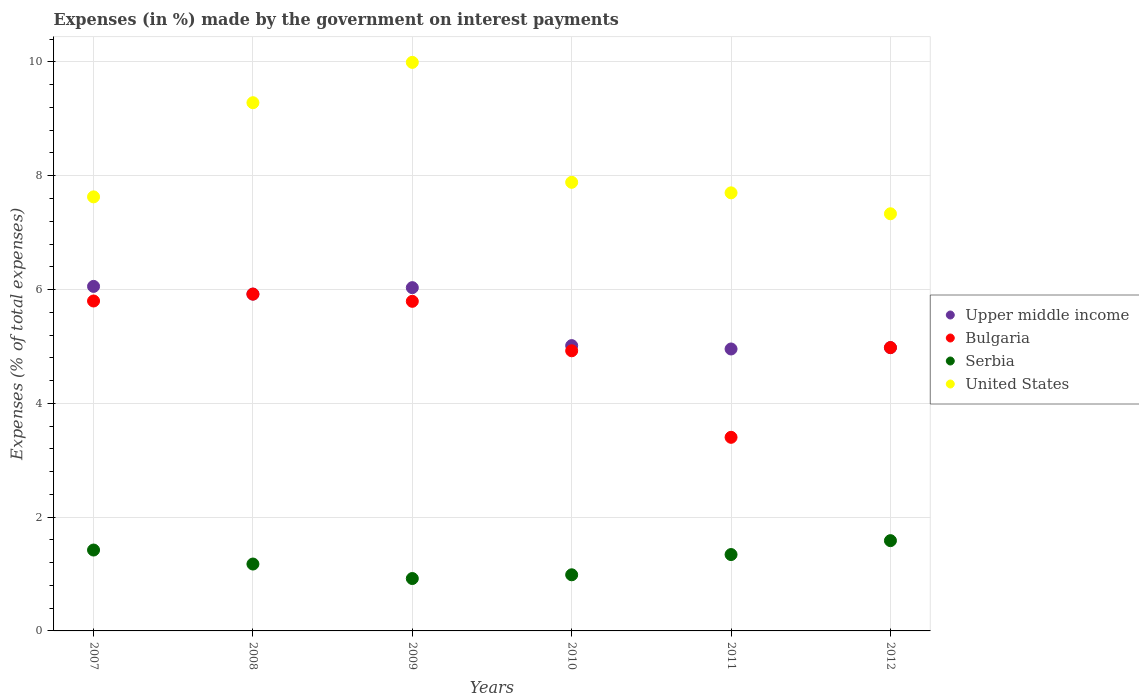How many different coloured dotlines are there?
Make the answer very short. 4. Is the number of dotlines equal to the number of legend labels?
Give a very brief answer. Yes. What is the percentage of expenses made by the government on interest payments in United States in 2008?
Your response must be concise. 9.28. Across all years, what is the maximum percentage of expenses made by the government on interest payments in Bulgaria?
Provide a succinct answer. 5.92. Across all years, what is the minimum percentage of expenses made by the government on interest payments in Bulgaria?
Provide a short and direct response. 3.4. In which year was the percentage of expenses made by the government on interest payments in Bulgaria maximum?
Offer a very short reply. 2008. What is the total percentage of expenses made by the government on interest payments in Serbia in the graph?
Ensure brevity in your answer.  7.43. What is the difference between the percentage of expenses made by the government on interest payments in Upper middle income in 2010 and that in 2012?
Offer a very short reply. 0.03. What is the difference between the percentage of expenses made by the government on interest payments in United States in 2008 and the percentage of expenses made by the government on interest payments in Upper middle income in 2009?
Give a very brief answer. 3.25. What is the average percentage of expenses made by the government on interest payments in Upper middle income per year?
Your answer should be very brief. 5.49. In the year 2010, what is the difference between the percentage of expenses made by the government on interest payments in United States and percentage of expenses made by the government on interest payments in Bulgaria?
Offer a very short reply. 2.96. What is the ratio of the percentage of expenses made by the government on interest payments in Serbia in 2007 to that in 2012?
Make the answer very short. 0.9. What is the difference between the highest and the second highest percentage of expenses made by the government on interest payments in Bulgaria?
Your answer should be compact. 0.12. What is the difference between the highest and the lowest percentage of expenses made by the government on interest payments in Bulgaria?
Offer a very short reply. 2.52. Is the sum of the percentage of expenses made by the government on interest payments in Bulgaria in 2010 and 2011 greater than the maximum percentage of expenses made by the government on interest payments in Upper middle income across all years?
Your answer should be very brief. Yes. Is it the case that in every year, the sum of the percentage of expenses made by the government on interest payments in United States and percentage of expenses made by the government on interest payments in Upper middle income  is greater than the sum of percentage of expenses made by the government on interest payments in Bulgaria and percentage of expenses made by the government on interest payments in Serbia?
Your answer should be compact. Yes. Is it the case that in every year, the sum of the percentage of expenses made by the government on interest payments in United States and percentage of expenses made by the government on interest payments in Bulgaria  is greater than the percentage of expenses made by the government on interest payments in Upper middle income?
Ensure brevity in your answer.  Yes. Does the percentage of expenses made by the government on interest payments in Serbia monotonically increase over the years?
Provide a short and direct response. No. Is the percentage of expenses made by the government on interest payments in United States strictly greater than the percentage of expenses made by the government on interest payments in Upper middle income over the years?
Your response must be concise. Yes. Is the percentage of expenses made by the government on interest payments in Bulgaria strictly less than the percentage of expenses made by the government on interest payments in Upper middle income over the years?
Your answer should be compact. No. How many dotlines are there?
Provide a short and direct response. 4. How many years are there in the graph?
Make the answer very short. 6. What is the difference between two consecutive major ticks on the Y-axis?
Make the answer very short. 2. Are the values on the major ticks of Y-axis written in scientific E-notation?
Ensure brevity in your answer.  No. Does the graph contain any zero values?
Provide a short and direct response. No. How many legend labels are there?
Make the answer very short. 4. How are the legend labels stacked?
Your answer should be very brief. Vertical. What is the title of the graph?
Provide a succinct answer. Expenses (in %) made by the government on interest payments. Does "Czech Republic" appear as one of the legend labels in the graph?
Your response must be concise. No. What is the label or title of the Y-axis?
Make the answer very short. Expenses (% of total expenses). What is the Expenses (% of total expenses) in Upper middle income in 2007?
Give a very brief answer. 6.05. What is the Expenses (% of total expenses) in Bulgaria in 2007?
Offer a terse response. 5.8. What is the Expenses (% of total expenses) of Serbia in 2007?
Give a very brief answer. 1.42. What is the Expenses (% of total expenses) in United States in 2007?
Keep it short and to the point. 7.63. What is the Expenses (% of total expenses) in Upper middle income in 2008?
Ensure brevity in your answer.  5.92. What is the Expenses (% of total expenses) in Bulgaria in 2008?
Provide a succinct answer. 5.92. What is the Expenses (% of total expenses) of Serbia in 2008?
Your response must be concise. 1.18. What is the Expenses (% of total expenses) in United States in 2008?
Provide a succinct answer. 9.28. What is the Expenses (% of total expenses) of Upper middle income in 2009?
Give a very brief answer. 6.03. What is the Expenses (% of total expenses) in Bulgaria in 2009?
Your answer should be very brief. 5.79. What is the Expenses (% of total expenses) in Serbia in 2009?
Offer a terse response. 0.92. What is the Expenses (% of total expenses) of United States in 2009?
Give a very brief answer. 9.99. What is the Expenses (% of total expenses) in Upper middle income in 2010?
Make the answer very short. 5.01. What is the Expenses (% of total expenses) in Bulgaria in 2010?
Keep it short and to the point. 4.92. What is the Expenses (% of total expenses) of Serbia in 2010?
Provide a succinct answer. 0.99. What is the Expenses (% of total expenses) in United States in 2010?
Your response must be concise. 7.88. What is the Expenses (% of total expenses) of Upper middle income in 2011?
Make the answer very short. 4.96. What is the Expenses (% of total expenses) of Bulgaria in 2011?
Offer a very short reply. 3.4. What is the Expenses (% of total expenses) in Serbia in 2011?
Make the answer very short. 1.34. What is the Expenses (% of total expenses) of United States in 2011?
Keep it short and to the point. 7.7. What is the Expenses (% of total expenses) in Upper middle income in 2012?
Your response must be concise. 4.98. What is the Expenses (% of total expenses) of Bulgaria in 2012?
Your answer should be compact. 4.98. What is the Expenses (% of total expenses) of Serbia in 2012?
Your answer should be very brief. 1.59. What is the Expenses (% of total expenses) of United States in 2012?
Provide a succinct answer. 7.33. Across all years, what is the maximum Expenses (% of total expenses) in Upper middle income?
Your answer should be very brief. 6.05. Across all years, what is the maximum Expenses (% of total expenses) of Bulgaria?
Make the answer very short. 5.92. Across all years, what is the maximum Expenses (% of total expenses) in Serbia?
Offer a very short reply. 1.59. Across all years, what is the maximum Expenses (% of total expenses) in United States?
Offer a terse response. 9.99. Across all years, what is the minimum Expenses (% of total expenses) in Upper middle income?
Give a very brief answer. 4.96. Across all years, what is the minimum Expenses (% of total expenses) of Bulgaria?
Provide a short and direct response. 3.4. Across all years, what is the minimum Expenses (% of total expenses) of Serbia?
Keep it short and to the point. 0.92. Across all years, what is the minimum Expenses (% of total expenses) of United States?
Your answer should be very brief. 7.33. What is the total Expenses (% of total expenses) in Upper middle income in the graph?
Ensure brevity in your answer.  32.96. What is the total Expenses (% of total expenses) in Bulgaria in the graph?
Your answer should be very brief. 30.82. What is the total Expenses (% of total expenses) in Serbia in the graph?
Your answer should be compact. 7.43. What is the total Expenses (% of total expenses) of United States in the graph?
Provide a succinct answer. 49.82. What is the difference between the Expenses (% of total expenses) of Upper middle income in 2007 and that in 2008?
Offer a terse response. 0.14. What is the difference between the Expenses (% of total expenses) in Bulgaria in 2007 and that in 2008?
Keep it short and to the point. -0.12. What is the difference between the Expenses (% of total expenses) in Serbia in 2007 and that in 2008?
Your answer should be very brief. 0.25. What is the difference between the Expenses (% of total expenses) of United States in 2007 and that in 2008?
Your answer should be compact. -1.66. What is the difference between the Expenses (% of total expenses) in Upper middle income in 2007 and that in 2009?
Give a very brief answer. 0.02. What is the difference between the Expenses (% of total expenses) in Bulgaria in 2007 and that in 2009?
Provide a succinct answer. 0.01. What is the difference between the Expenses (% of total expenses) of Serbia in 2007 and that in 2009?
Ensure brevity in your answer.  0.5. What is the difference between the Expenses (% of total expenses) in United States in 2007 and that in 2009?
Give a very brief answer. -2.36. What is the difference between the Expenses (% of total expenses) in Upper middle income in 2007 and that in 2010?
Make the answer very short. 1.04. What is the difference between the Expenses (% of total expenses) of Serbia in 2007 and that in 2010?
Offer a terse response. 0.44. What is the difference between the Expenses (% of total expenses) of United States in 2007 and that in 2010?
Offer a very short reply. -0.26. What is the difference between the Expenses (% of total expenses) of Upper middle income in 2007 and that in 2011?
Keep it short and to the point. 1.1. What is the difference between the Expenses (% of total expenses) in Bulgaria in 2007 and that in 2011?
Offer a very short reply. 2.4. What is the difference between the Expenses (% of total expenses) of Serbia in 2007 and that in 2011?
Ensure brevity in your answer.  0.08. What is the difference between the Expenses (% of total expenses) of United States in 2007 and that in 2011?
Provide a succinct answer. -0.07. What is the difference between the Expenses (% of total expenses) of Upper middle income in 2007 and that in 2012?
Provide a short and direct response. 1.08. What is the difference between the Expenses (% of total expenses) in Bulgaria in 2007 and that in 2012?
Your answer should be compact. 0.82. What is the difference between the Expenses (% of total expenses) of Serbia in 2007 and that in 2012?
Offer a very short reply. -0.16. What is the difference between the Expenses (% of total expenses) in United States in 2007 and that in 2012?
Offer a terse response. 0.3. What is the difference between the Expenses (% of total expenses) of Upper middle income in 2008 and that in 2009?
Your response must be concise. -0.11. What is the difference between the Expenses (% of total expenses) of Bulgaria in 2008 and that in 2009?
Give a very brief answer. 0.13. What is the difference between the Expenses (% of total expenses) of Serbia in 2008 and that in 2009?
Provide a short and direct response. 0.25. What is the difference between the Expenses (% of total expenses) in United States in 2008 and that in 2009?
Give a very brief answer. -0.71. What is the difference between the Expenses (% of total expenses) of Upper middle income in 2008 and that in 2010?
Your answer should be very brief. 0.91. What is the difference between the Expenses (% of total expenses) in Serbia in 2008 and that in 2010?
Offer a very short reply. 0.19. What is the difference between the Expenses (% of total expenses) of United States in 2008 and that in 2010?
Give a very brief answer. 1.4. What is the difference between the Expenses (% of total expenses) in Upper middle income in 2008 and that in 2011?
Your answer should be very brief. 0.96. What is the difference between the Expenses (% of total expenses) in Bulgaria in 2008 and that in 2011?
Ensure brevity in your answer.  2.52. What is the difference between the Expenses (% of total expenses) in Serbia in 2008 and that in 2011?
Make the answer very short. -0.17. What is the difference between the Expenses (% of total expenses) in United States in 2008 and that in 2011?
Your answer should be very brief. 1.58. What is the difference between the Expenses (% of total expenses) in Upper middle income in 2008 and that in 2012?
Your answer should be very brief. 0.94. What is the difference between the Expenses (% of total expenses) of Bulgaria in 2008 and that in 2012?
Ensure brevity in your answer.  0.94. What is the difference between the Expenses (% of total expenses) of Serbia in 2008 and that in 2012?
Offer a very short reply. -0.41. What is the difference between the Expenses (% of total expenses) in United States in 2008 and that in 2012?
Your answer should be compact. 1.95. What is the difference between the Expenses (% of total expenses) in Upper middle income in 2009 and that in 2010?
Offer a terse response. 1.02. What is the difference between the Expenses (% of total expenses) in Bulgaria in 2009 and that in 2010?
Provide a succinct answer. 0.87. What is the difference between the Expenses (% of total expenses) in Serbia in 2009 and that in 2010?
Offer a terse response. -0.07. What is the difference between the Expenses (% of total expenses) of United States in 2009 and that in 2010?
Keep it short and to the point. 2.11. What is the difference between the Expenses (% of total expenses) of Upper middle income in 2009 and that in 2011?
Your answer should be very brief. 1.08. What is the difference between the Expenses (% of total expenses) in Bulgaria in 2009 and that in 2011?
Make the answer very short. 2.39. What is the difference between the Expenses (% of total expenses) of Serbia in 2009 and that in 2011?
Your answer should be compact. -0.42. What is the difference between the Expenses (% of total expenses) of United States in 2009 and that in 2011?
Offer a very short reply. 2.29. What is the difference between the Expenses (% of total expenses) in Upper middle income in 2009 and that in 2012?
Your answer should be compact. 1.05. What is the difference between the Expenses (% of total expenses) in Bulgaria in 2009 and that in 2012?
Keep it short and to the point. 0.81. What is the difference between the Expenses (% of total expenses) of Serbia in 2009 and that in 2012?
Ensure brevity in your answer.  -0.67. What is the difference between the Expenses (% of total expenses) of United States in 2009 and that in 2012?
Ensure brevity in your answer.  2.66. What is the difference between the Expenses (% of total expenses) in Upper middle income in 2010 and that in 2011?
Your answer should be compact. 0.06. What is the difference between the Expenses (% of total expenses) in Bulgaria in 2010 and that in 2011?
Give a very brief answer. 1.52. What is the difference between the Expenses (% of total expenses) in Serbia in 2010 and that in 2011?
Keep it short and to the point. -0.36. What is the difference between the Expenses (% of total expenses) in United States in 2010 and that in 2011?
Keep it short and to the point. 0.19. What is the difference between the Expenses (% of total expenses) of Upper middle income in 2010 and that in 2012?
Offer a terse response. 0.03. What is the difference between the Expenses (% of total expenses) of Bulgaria in 2010 and that in 2012?
Provide a short and direct response. -0.06. What is the difference between the Expenses (% of total expenses) of United States in 2010 and that in 2012?
Provide a succinct answer. 0.55. What is the difference between the Expenses (% of total expenses) in Upper middle income in 2011 and that in 2012?
Offer a terse response. -0.02. What is the difference between the Expenses (% of total expenses) in Bulgaria in 2011 and that in 2012?
Give a very brief answer. -1.58. What is the difference between the Expenses (% of total expenses) of Serbia in 2011 and that in 2012?
Offer a very short reply. -0.24. What is the difference between the Expenses (% of total expenses) of United States in 2011 and that in 2012?
Make the answer very short. 0.37. What is the difference between the Expenses (% of total expenses) in Upper middle income in 2007 and the Expenses (% of total expenses) in Bulgaria in 2008?
Give a very brief answer. 0.14. What is the difference between the Expenses (% of total expenses) in Upper middle income in 2007 and the Expenses (% of total expenses) in Serbia in 2008?
Provide a succinct answer. 4.88. What is the difference between the Expenses (% of total expenses) of Upper middle income in 2007 and the Expenses (% of total expenses) of United States in 2008?
Keep it short and to the point. -3.23. What is the difference between the Expenses (% of total expenses) of Bulgaria in 2007 and the Expenses (% of total expenses) of Serbia in 2008?
Offer a terse response. 4.62. What is the difference between the Expenses (% of total expenses) in Bulgaria in 2007 and the Expenses (% of total expenses) in United States in 2008?
Make the answer very short. -3.48. What is the difference between the Expenses (% of total expenses) in Serbia in 2007 and the Expenses (% of total expenses) in United States in 2008?
Give a very brief answer. -7.86. What is the difference between the Expenses (% of total expenses) in Upper middle income in 2007 and the Expenses (% of total expenses) in Bulgaria in 2009?
Your answer should be compact. 0.26. What is the difference between the Expenses (% of total expenses) in Upper middle income in 2007 and the Expenses (% of total expenses) in Serbia in 2009?
Offer a terse response. 5.13. What is the difference between the Expenses (% of total expenses) in Upper middle income in 2007 and the Expenses (% of total expenses) in United States in 2009?
Provide a succinct answer. -3.94. What is the difference between the Expenses (% of total expenses) of Bulgaria in 2007 and the Expenses (% of total expenses) of Serbia in 2009?
Provide a short and direct response. 4.88. What is the difference between the Expenses (% of total expenses) of Bulgaria in 2007 and the Expenses (% of total expenses) of United States in 2009?
Ensure brevity in your answer.  -4.19. What is the difference between the Expenses (% of total expenses) in Serbia in 2007 and the Expenses (% of total expenses) in United States in 2009?
Offer a very short reply. -8.57. What is the difference between the Expenses (% of total expenses) of Upper middle income in 2007 and the Expenses (% of total expenses) of Bulgaria in 2010?
Make the answer very short. 1.13. What is the difference between the Expenses (% of total expenses) in Upper middle income in 2007 and the Expenses (% of total expenses) in Serbia in 2010?
Give a very brief answer. 5.07. What is the difference between the Expenses (% of total expenses) in Upper middle income in 2007 and the Expenses (% of total expenses) in United States in 2010?
Offer a very short reply. -1.83. What is the difference between the Expenses (% of total expenses) in Bulgaria in 2007 and the Expenses (% of total expenses) in Serbia in 2010?
Make the answer very short. 4.81. What is the difference between the Expenses (% of total expenses) in Bulgaria in 2007 and the Expenses (% of total expenses) in United States in 2010?
Your response must be concise. -2.09. What is the difference between the Expenses (% of total expenses) of Serbia in 2007 and the Expenses (% of total expenses) of United States in 2010?
Your answer should be compact. -6.46. What is the difference between the Expenses (% of total expenses) of Upper middle income in 2007 and the Expenses (% of total expenses) of Bulgaria in 2011?
Ensure brevity in your answer.  2.65. What is the difference between the Expenses (% of total expenses) in Upper middle income in 2007 and the Expenses (% of total expenses) in Serbia in 2011?
Give a very brief answer. 4.71. What is the difference between the Expenses (% of total expenses) in Upper middle income in 2007 and the Expenses (% of total expenses) in United States in 2011?
Your answer should be very brief. -1.64. What is the difference between the Expenses (% of total expenses) in Bulgaria in 2007 and the Expenses (% of total expenses) in Serbia in 2011?
Provide a short and direct response. 4.46. What is the difference between the Expenses (% of total expenses) of Bulgaria in 2007 and the Expenses (% of total expenses) of United States in 2011?
Give a very brief answer. -1.9. What is the difference between the Expenses (% of total expenses) in Serbia in 2007 and the Expenses (% of total expenses) in United States in 2011?
Provide a succinct answer. -6.28. What is the difference between the Expenses (% of total expenses) of Upper middle income in 2007 and the Expenses (% of total expenses) of Bulgaria in 2012?
Your response must be concise. 1.08. What is the difference between the Expenses (% of total expenses) in Upper middle income in 2007 and the Expenses (% of total expenses) in Serbia in 2012?
Your answer should be very brief. 4.47. What is the difference between the Expenses (% of total expenses) of Upper middle income in 2007 and the Expenses (% of total expenses) of United States in 2012?
Your answer should be compact. -1.28. What is the difference between the Expenses (% of total expenses) of Bulgaria in 2007 and the Expenses (% of total expenses) of Serbia in 2012?
Your answer should be very brief. 4.21. What is the difference between the Expenses (% of total expenses) of Bulgaria in 2007 and the Expenses (% of total expenses) of United States in 2012?
Your answer should be compact. -1.53. What is the difference between the Expenses (% of total expenses) of Serbia in 2007 and the Expenses (% of total expenses) of United States in 2012?
Your response must be concise. -5.91. What is the difference between the Expenses (% of total expenses) in Upper middle income in 2008 and the Expenses (% of total expenses) in Bulgaria in 2009?
Offer a very short reply. 0.13. What is the difference between the Expenses (% of total expenses) of Upper middle income in 2008 and the Expenses (% of total expenses) of Serbia in 2009?
Provide a succinct answer. 5. What is the difference between the Expenses (% of total expenses) of Upper middle income in 2008 and the Expenses (% of total expenses) of United States in 2009?
Give a very brief answer. -4.07. What is the difference between the Expenses (% of total expenses) in Bulgaria in 2008 and the Expenses (% of total expenses) in Serbia in 2009?
Ensure brevity in your answer.  5. What is the difference between the Expenses (% of total expenses) in Bulgaria in 2008 and the Expenses (% of total expenses) in United States in 2009?
Offer a very short reply. -4.07. What is the difference between the Expenses (% of total expenses) of Serbia in 2008 and the Expenses (% of total expenses) of United States in 2009?
Your answer should be compact. -8.82. What is the difference between the Expenses (% of total expenses) in Upper middle income in 2008 and the Expenses (% of total expenses) in Serbia in 2010?
Your response must be concise. 4.93. What is the difference between the Expenses (% of total expenses) in Upper middle income in 2008 and the Expenses (% of total expenses) in United States in 2010?
Give a very brief answer. -1.96. What is the difference between the Expenses (% of total expenses) of Bulgaria in 2008 and the Expenses (% of total expenses) of Serbia in 2010?
Offer a very short reply. 4.93. What is the difference between the Expenses (% of total expenses) of Bulgaria in 2008 and the Expenses (% of total expenses) of United States in 2010?
Ensure brevity in your answer.  -1.96. What is the difference between the Expenses (% of total expenses) in Serbia in 2008 and the Expenses (% of total expenses) in United States in 2010?
Your response must be concise. -6.71. What is the difference between the Expenses (% of total expenses) of Upper middle income in 2008 and the Expenses (% of total expenses) of Bulgaria in 2011?
Your answer should be very brief. 2.52. What is the difference between the Expenses (% of total expenses) of Upper middle income in 2008 and the Expenses (% of total expenses) of Serbia in 2011?
Offer a terse response. 4.58. What is the difference between the Expenses (% of total expenses) in Upper middle income in 2008 and the Expenses (% of total expenses) in United States in 2011?
Give a very brief answer. -1.78. What is the difference between the Expenses (% of total expenses) of Bulgaria in 2008 and the Expenses (% of total expenses) of Serbia in 2011?
Keep it short and to the point. 4.58. What is the difference between the Expenses (% of total expenses) in Bulgaria in 2008 and the Expenses (% of total expenses) in United States in 2011?
Your answer should be very brief. -1.78. What is the difference between the Expenses (% of total expenses) of Serbia in 2008 and the Expenses (% of total expenses) of United States in 2011?
Give a very brief answer. -6.52. What is the difference between the Expenses (% of total expenses) of Upper middle income in 2008 and the Expenses (% of total expenses) of Bulgaria in 2012?
Keep it short and to the point. 0.94. What is the difference between the Expenses (% of total expenses) of Upper middle income in 2008 and the Expenses (% of total expenses) of Serbia in 2012?
Ensure brevity in your answer.  4.33. What is the difference between the Expenses (% of total expenses) in Upper middle income in 2008 and the Expenses (% of total expenses) in United States in 2012?
Offer a very short reply. -1.41. What is the difference between the Expenses (% of total expenses) of Bulgaria in 2008 and the Expenses (% of total expenses) of Serbia in 2012?
Provide a succinct answer. 4.33. What is the difference between the Expenses (% of total expenses) in Bulgaria in 2008 and the Expenses (% of total expenses) in United States in 2012?
Keep it short and to the point. -1.41. What is the difference between the Expenses (% of total expenses) of Serbia in 2008 and the Expenses (% of total expenses) of United States in 2012?
Your response must be concise. -6.16. What is the difference between the Expenses (% of total expenses) of Upper middle income in 2009 and the Expenses (% of total expenses) of Bulgaria in 2010?
Give a very brief answer. 1.11. What is the difference between the Expenses (% of total expenses) of Upper middle income in 2009 and the Expenses (% of total expenses) of Serbia in 2010?
Your response must be concise. 5.05. What is the difference between the Expenses (% of total expenses) of Upper middle income in 2009 and the Expenses (% of total expenses) of United States in 2010?
Your answer should be very brief. -1.85. What is the difference between the Expenses (% of total expenses) in Bulgaria in 2009 and the Expenses (% of total expenses) in Serbia in 2010?
Make the answer very short. 4.81. What is the difference between the Expenses (% of total expenses) of Bulgaria in 2009 and the Expenses (% of total expenses) of United States in 2010?
Your answer should be compact. -2.09. What is the difference between the Expenses (% of total expenses) of Serbia in 2009 and the Expenses (% of total expenses) of United States in 2010?
Ensure brevity in your answer.  -6.96. What is the difference between the Expenses (% of total expenses) in Upper middle income in 2009 and the Expenses (% of total expenses) in Bulgaria in 2011?
Your response must be concise. 2.63. What is the difference between the Expenses (% of total expenses) in Upper middle income in 2009 and the Expenses (% of total expenses) in Serbia in 2011?
Offer a very short reply. 4.69. What is the difference between the Expenses (% of total expenses) in Upper middle income in 2009 and the Expenses (% of total expenses) in United States in 2011?
Your answer should be compact. -1.67. What is the difference between the Expenses (% of total expenses) in Bulgaria in 2009 and the Expenses (% of total expenses) in Serbia in 2011?
Make the answer very short. 4.45. What is the difference between the Expenses (% of total expenses) of Bulgaria in 2009 and the Expenses (% of total expenses) of United States in 2011?
Your answer should be very brief. -1.91. What is the difference between the Expenses (% of total expenses) of Serbia in 2009 and the Expenses (% of total expenses) of United States in 2011?
Offer a terse response. -6.78. What is the difference between the Expenses (% of total expenses) of Upper middle income in 2009 and the Expenses (% of total expenses) of Bulgaria in 2012?
Make the answer very short. 1.05. What is the difference between the Expenses (% of total expenses) in Upper middle income in 2009 and the Expenses (% of total expenses) in Serbia in 2012?
Your response must be concise. 4.45. What is the difference between the Expenses (% of total expenses) in Upper middle income in 2009 and the Expenses (% of total expenses) in United States in 2012?
Your answer should be very brief. -1.3. What is the difference between the Expenses (% of total expenses) in Bulgaria in 2009 and the Expenses (% of total expenses) in Serbia in 2012?
Offer a very short reply. 4.21. What is the difference between the Expenses (% of total expenses) in Bulgaria in 2009 and the Expenses (% of total expenses) in United States in 2012?
Provide a short and direct response. -1.54. What is the difference between the Expenses (% of total expenses) in Serbia in 2009 and the Expenses (% of total expenses) in United States in 2012?
Your answer should be compact. -6.41. What is the difference between the Expenses (% of total expenses) in Upper middle income in 2010 and the Expenses (% of total expenses) in Bulgaria in 2011?
Ensure brevity in your answer.  1.61. What is the difference between the Expenses (% of total expenses) in Upper middle income in 2010 and the Expenses (% of total expenses) in Serbia in 2011?
Your answer should be very brief. 3.67. What is the difference between the Expenses (% of total expenses) of Upper middle income in 2010 and the Expenses (% of total expenses) of United States in 2011?
Make the answer very short. -2.68. What is the difference between the Expenses (% of total expenses) of Bulgaria in 2010 and the Expenses (% of total expenses) of Serbia in 2011?
Give a very brief answer. 3.58. What is the difference between the Expenses (% of total expenses) in Bulgaria in 2010 and the Expenses (% of total expenses) in United States in 2011?
Make the answer very short. -2.78. What is the difference between the Expenses (% of total expenses) of Serbia in 2010 and the Expenses (% of total expenses) of United States in 2011?
Keep it short and to the point. -6.71. What is the difference between the Expenses (% of total expenses) of Upper middle income in 2010 and the Expenses (% of total expenses) of Bulgaria in 2012?
Your answer should be compact. 0.03. What is the difference between the Expenses (% of total expenses) of Upper middle income in 2010 and the Expenses (% of total expenses) of Serbia in 2012?
Provide a succinct answer. 3.43. What is the difference between the Expenses (% of total expenses) of Upper middle income in 2010 and the Expenses (% of total expenses) of United States in 2012?
Your response must be concise. -2.32. What is the difference between the Expenses (% of total expenses) of Bulgaria in 2010 and the Expenses (% of total expenses) of Serbia in 2012?
Make the answer very short. 3.34. What is the difference between the Expenses (% of total expenses) in Bulgaria in 2010 and the Expenses (% of total expenses) in United States in 2012?
Offer a terse response. -2.41. What is the difference between the Expenses (% of total expenses) in Serbia in 2010 and the Expenses (% of total expenses) in United States in 2012?
Your answer should be compact. -6.34. What is the difference between the Expenses (% of total expenses) in Upper middle income in 2011 and the Expenses (% of total expenses) in Bulgaria in 2012?
Make the answer very short. -0.02. What is the difference between the Expenses (% of total expenses) of Upper middle income in 2011 and the Expenses (% of total expenses) of Serbia in 2012?
Your response must be concise. 3.37. What is the difference between the Expenses (% of total expenses) of Upper middle income in 2011 and the Expenses (% of total expenses) of United States in 2012?
Keep it short and to the point. -2.38. What is the difference between the Expenses (% of total expenses) in Bulgaria in 2011 and the Expenses (% of total expenses) in Serbia in 2012?
Keep it short and to the point. 1.82. What is the difference between the Expenses (% of total expenses) of Bulgaria in 2011 and the Expenses (% of total expenses) of United States in 2012?
Offer a very short reply. -3.93. What is the difference between the Expenses (% of total expenses) of Serbia in 2011 and the Expenses (% of total expenses) of United States in 2012?
Offer a terse response. -5.99. What is the average Expenses (% of total expenses) in Upper middle income per year?
Offer a very short reply. 5.49. What is the average Expenses (% of total expenses) in Bulgaria per year?
Make the answer very short. 5.14. What is the average Expenses (% of total expenses) of Serbia per year?
Keep it short and to the point. 1.24. What is the average Expenses (% of total expenses) in United States per year?
Offer a very short reply. 8.3. In the year 2007, what is the difference between the Expenses (% of total expenses) of Upper middle income and Expenses (% of total expenses) of Bulgaria?
Your response must be concise. 0.26. In the year 2007, what is the difference between the Expenses (% of total expenses) in Upper middle income and Expenses (% of total expenses) in Serbia?
Your answer should be very brief. 4.63. In the year 2007, what is the difference between the Expenses (% of total expenses) of Upper middle income and Expenses (% of total expenses) of United States?
Provide a succinct answer. -1.57. In the year 2007, what is the difference between the Expenses (% of total expenses) in Bulgaria and Expenses (% of total expenses) in Serbia?
Provide a succinct answer. 4.38. In the year 2007, what is the difference between the Expenses (% of total expenses) of Bulgaria and Expenses (% of total expenses) of United States?
Your answer should be compact. -1.83. In the year 2007, what is the difference between the Expenses (% of total expenses) in Serbia and Expenses (% of total expenses) in United States?
Your answer should be compact. -6.21. In the year 2008, what is the difference between the Expenses (% of total expenses) of Upper middle income and Expenses (% of total expenses) of Serbia?
Provide a short and direct response. 4.74. In the year 2008, what is the difference between the Expenses (% of total expenses) of Upper middle income and Expenses (% of total expenses) of United States?
Provide a short and direct response. -3.36. In the year 2008, what is the difference between the Expenses (% of total expenses) in Bulgaria and Expenses (% of total expenses) in Serbia?
Provide a succinct answer. 4.74. In the year 2008, what is the difference between the Expenses (% of total expenses) in Bulgaria and Expenses (% of total expenses) in United States?
Ensure brevity in your answer.  -3.36. In the year 2008, what is the difference between the Expenses (% of total expenses) of Serbia and Expenses (% of total expenses) of United States?
Offer a terse response. -8.11. In the year 2009, what is the difference between the Expenses (% of total expenses) in Upper middle income and Expenses (% of total expenses) in Bulgaria?
Make the answer very short. 0.24. In the year 2009, what is the difference between the Expenses (% of total expenses) in Upper middle income and Expenses (% of total expenses) in Serbia?
Provide a succinct answer. 5.11. In the year 2009, what is the difference between the Expenses (% of total expenses) of Upper middle income and Expenses (% of total expenses) of United States?
Offer a very short reply. -3.96. In the year 2009, what is the difference between the Expenses (% of total expenses) in Bulgaria and Expenses (% of total expenses) in Serbia?
Give a very brief answer. 4.87. In the year 2009, what is the difference between the Expenses (% of total expenses) in Bulgaria and Expenses (% of total expenses) in United States?
Offer a terse response. -4.2. In the year 2009, what is the difference between the Expenses (% of total expenses) of Serbia and Expenses (% of total expenses) of United States?
Your answer should be compact. -9.07. In the year 2010, what is the difference between the Expenses (% of total expenses) in Upper middle income and Expenses (% of total expenses) in Bulgaria?
Make the answer very short. 0.09. In the year 2010, what is the difference between the Expenses (% of total expenses) of Upper middle income and Expenses (% of total expenses) of Serbia?
Provide a short and direct response. 4.03. In the year 2010, what is the difference between the Expenses (% of total expenses) in Upper middle income and Expenses (% of total expenses) in United States?
Provide a succinct answer. -2.87. In the year 2010, what is the difference between the Expenses (% of total expenses) in Bulgaria and Expenses (% of total expenses) in Serbia?
Make the answer very short. 3.94. In the year 2010, what is the difference between the Expenses (% of total expenses) in Bulgaria and Expenses (% of total expenses) in United States?
Keep it short and to the point. -2.96. In the year 2010, what is the difference between the Expenses (% of total expenses) of Serbia and Expenses (% of total expenses) of United States?
Offer a very short reply. -6.9. In the year 2011, what is the difference between the Expenses (% of total expenses) of Upper middle income and Expenses (% of total expenses) of Bulgaria?
Give a very brief answer. 1.55. In the year 2011, what is the difference between the Expenses (% of total expenses) in Upper middle income and Expenses (% of total expenses) in Serbia?
Your answer should be very brief. 3.61. In the year 2011, what is the difference between the Expenses (% of total expenses) of Upper middle income and Expenses (% of total expenses) of United States?
Keep it short and to the point. -2.74. In the year 2011, what is the difference between the Expenses (% of total expenses) of Bulgaria and Expenses (% of total expenses) of Serbia?
Make the answer very short. 2.06. In the year 2011, what is the difference between the Expenses (% of total expenses) in Bulgaria and Expenses (% of total expenses) in United States?
Your answer should be very brief. -4.3. In the year 2011, what is the difference between the Expenses (% of total expenses) in Serbia and Expenses (% of total expenses) in United States?
Offer a terse response. -6.36. In the year 2012, what is the difference between the Expenses (% of total expenses) of Upper middle income and Expenses (% of total expenses) of Serbia?
Your response must be concise. 3.39. In the year 2012, what is the difference between the Expenses (% of total expenses) of Upper middle income and Expenses (% of total expenses) of United States?
Give a very brief answer. -2.35. In the year 2012, what is the difference between the Expenses (% of total expenses) of Bulgaria and Expenses (% of total expenses) of Serbia?
Keep it short and to the point. 3.39. In the year 2012, what is the difference between the Expenses (% of total expenses) in Bulgaria and Expenses (% of total expenses) in United States?
Offer a terse response. -2.35. In the year 2012, what is the difference between the Expenses (% of total expenses) of Serbia and Expenses (% of total expenses) of United States?
Offer a very short reply. -5.74. What is the ratio of the Expenses (% of total expenses) in Upper middle income in 2007 to that in 2008?
Ensure brevity in your answer.  1.02. What is the ratio of the Expenses (% of total expenses) in Bulgaria in 2007 to that in 2008?
Offer a very short reply. 0.98. What is the ratio of the Expenses (% of total expenses) in Serbia in 2007 to that in 2008?
Your response must be concise. 1.21. What is the ratio of the Expenses (% of total expenses) in United States in 2007 to that in 2008?
Make the answer very short. 0.82. What is the ratio of the Expenses (% of total expenses) in Bulgaria in 2007 to that in 2009?
Provide a succinct answer. 1. What is the ratio of the Expenses (% of total expenses) of Serbia in 2007 to that in 2009?
Give a very brief answer. 1.54. What is the ratio of the Expenses (% of total expenses) in United States in 2007 to that in 2009?
Offer a terse response. 0.76. What is the ratio of the Expenses (% of total expenses) of Upper middle income in 2007 to that in 2010?
Keep it short and to the point. 1.21. What is the ratio of the Expenses (% of total expenses) in Bulgaria in 2007 to that in 2010?
Give a very brief answer. 1.18. What is the ratio of the Expenses (% of total expenses) of Serbia in 2007 to that in 2010?
Keep it short and to the point. 1.44. What is the ratio of the Expenses (% of total expenses) of United States in 2007 to that in 2010?
Give a very brief answer. 0.97. What is the ratio of the Expenses (% of total expenses) in Upper middle income in 2007 to that in 2011?
Keep it short and to the point. 1.22. What is the ratio of the Expenses (% of total expenses) in Bulgaria in 2007 to that in 2011?
Give a very brief answer. 1.7. What is the ratio of the Expenses (% of total expenses) in Serbia in 2007 to that in 2011?
Ensure brevity in your answer.  1.06. What is the ratio of the Expenses (% of total expenses) of Upper middle income in 2007 to that in 2012?
Make the answer very short. 1.22. What is the ratio of the Expenses (% of total expenses) in Bulgaria in 2007 to that in 2012?
Give a very brief answer. 1.16. What is the ratio of the Expenses (% of total expenses) in Serbia in 2007 to that in 2012?
Provide a short and direct response. 0.9. What is the ratio of the Expenses (% of total expenses) of United States in 2007 to that in 2012?
Your answer should be compact. 1.04. What is the ratio of the Expenses (% of total expenses) in Upper middle income in 2008 to that in 2009?
Give a very brief answer. 0.98. What is the ratio of the Expenses (% of total expenses) of Bulgaria in 2008 to that in 2009?
Ensure brevity in your answer.  1.02. What is the ratio of the Expenses (% of total expenses) in Serbia in 2008 to that in 2009?
Give a very brief answer. 1.28. What is the ratio of the Expenses (% of total expenses) of United States in 2008 to that in 2009?
Offer a terse response. 0.93. What is the ratio of the Expenses (% of total expenses) in Upper middle income in 2008 to that in 2010?
Your answer should be compact. 1.18. What is the ratio of the Expenses (% of total expenses) in Bulgaria in 2008 to that in 2010?
Your response must be concise. 1.2. What is the ratio of the Expenses (% of total expenses) of Serbia in 2008 to that in 2010?
Your answer should be compact. 1.19. What is the ratio of the Expenses (% of total expenses) of United States in 2008 to that in 2010?
Your answer should be compact. 1.18. What is the ratio of the Expenses (% of total expenses) in Upper middle income in 2008 to that in 2011?
Offer a terse response. 1.19. What is the ratio of the Expenses (% of total expenses) of Bulgaria in 2008 to that in 2011?
Your response must be concise. 1.74. What is the ratio of the Expenses (% of total expenses) in Serbia in 2008 to that in 2011?
Your answer should be compact. 0.88. What is the ratio of the Expenses (% of total expenses) in United States in 2008 to that in 2011?
Give a very brief answer. 1.21. What is the ratio of the Expenses (% of total expenses) in Upper middle income in 2008 to that in 2012?
Provide a succinct answer. 1.19. What is the ratio of the Expenses (% of total expenses) in Bulgaria in 2008 to that in 2012?
Offer a very short reply. 1.19. What is the ratio of the Expenses (% of total expenses) of Serbia in 2008 to that in 2012?
Your answer should be very brief. 0.74. What is the ratio of the Expenses (% of total expenses) in United States in 2008 to that in 2012?
Make the answer very short. 1.27. What is the ratio of the Expenses (% of total expenses) in Upper middle income in 2009 to that in 2010?
Your answer should be compact. 1.2. What is the ratio of the Expenses (% of total expenses) in Bulgaria in 2009 to that in 2010?
Your response must be concise. 1.18. What is the ratio of the Expenses (% of total expenses) of Serbia in 2009 to that in 2010?
Give a very brief answer. 0.93. What is the ratio of the Expenses (% of total expenses) in United States in 2009 to that in 2010?
Your answer should be very brief. 1.27. What is the ratio of the Expenses (% of total expenses) in Upper middle income in 2009 to that in 2011?
Your answer should be very brief. 1.22. What is the ratio of the Expenses (% of total expenses) in Bulgaria in 2009 to that in 2011?
Offer a very short reply. 1.7. What is the ratio of the Expenses (% of total expenses) of Serbia in 2009 to that in 2011?
Your answer should be very brief. 0.69. What is the ratio of the Expenses (% of total expenses) of United States in 2009 to that in 2011?
Provide a succinct answer. 1.3. What is the ratio of the Expenses (% of total expenses) in Upper middle income in 2009 to that in 2012?
Offer a very short reply. 1.21. What is the ratio of the Expenses (% of total expenses) in Bulgaria in 2009 to that in 2012?
Provide a succinct answer. 1.16. What is the ratio of the Expenses (% of total expenses) of Serbia in 2009 to that in 2012?
Ensure brevity in your answer.  0.58. What is the ratio of the Expenses (% of total expenses) in United States in 2009 to that in 2012?
Your answer should be compact. 1.36. What is the ratio of the Expenses (% of total expenses) in Upper middle income in 2010 to that in 2011?
Provide a short and direct response. 1.01. What is the ratio of the Expenses (% of total expenses) in Bulgaria in 2010 to that in 2011?
Your answer should be compact. 1.45. What is the ratio of the Expenses (% of total expenses) of Serbia in 2010 to that in 2011?
Your answer should be very brief. 0.73. What is the ratio of the Expenses (% of total expenses) of United States in 2010 to that in 2011?
Ensure brevity in your answer.  1.02. What is the ratio of the Expenses (% of total expenses) in Serbia in 2010 to that in 2012?
Ensure brevity in your answer.  0.62. What is the ratio of the Expenses (% of total expenses) of United States in 2010 to that in 2012?
Ensure brevity in your answer.  1.08. What is the ratio of the Expenses (% of total expenses) of Bulgaria in 2011 to that in 2012?
Give a very brief answer. 0.68. What is the ratio of the Expenses (% of total expenses) of Serbia in 2011 to that in 2012?
Offer a terse response. 0.85. What is the ratio of the Expenses (% of total expenses) in United States in 2011 to that in 2012?
Make the answer very short. 1.05. What is the difference between the highest and the second highest Expenses (% of total expenses) in Upper middle income?
Your response must be concise. 0.02. What is the difference between the highest and the second highest Expenses (% of total expenses) in Bulgaria?
Make the answer very short. 0.12. What is the difference between the highest and the second highest Expenses (% of total expenses) in Serbia?
Provide a succinct answer. 0.16. What is the difference between the highest and the second highest Expenses (% of total expenses) of United States?
Your answer should be very brief. 0.71. What is the difference between the highest and the lowest Expenses (% of total expenses) in Upper middle income?
Your answer should be compact. 1.1. What is the difference between the highest and the lowest Expenses (% of total expenses) of Bulgaria?
Your answer should be very brief. 2.52. What is the difference between the highest and the lowest Expenses (% of total expenses) of Serbia?
Offer a terse response. 0.67. What is the difference between the highest and the lowest Expenses (% of total expenses) in United States?
Offer a very short reply. 2.66. 